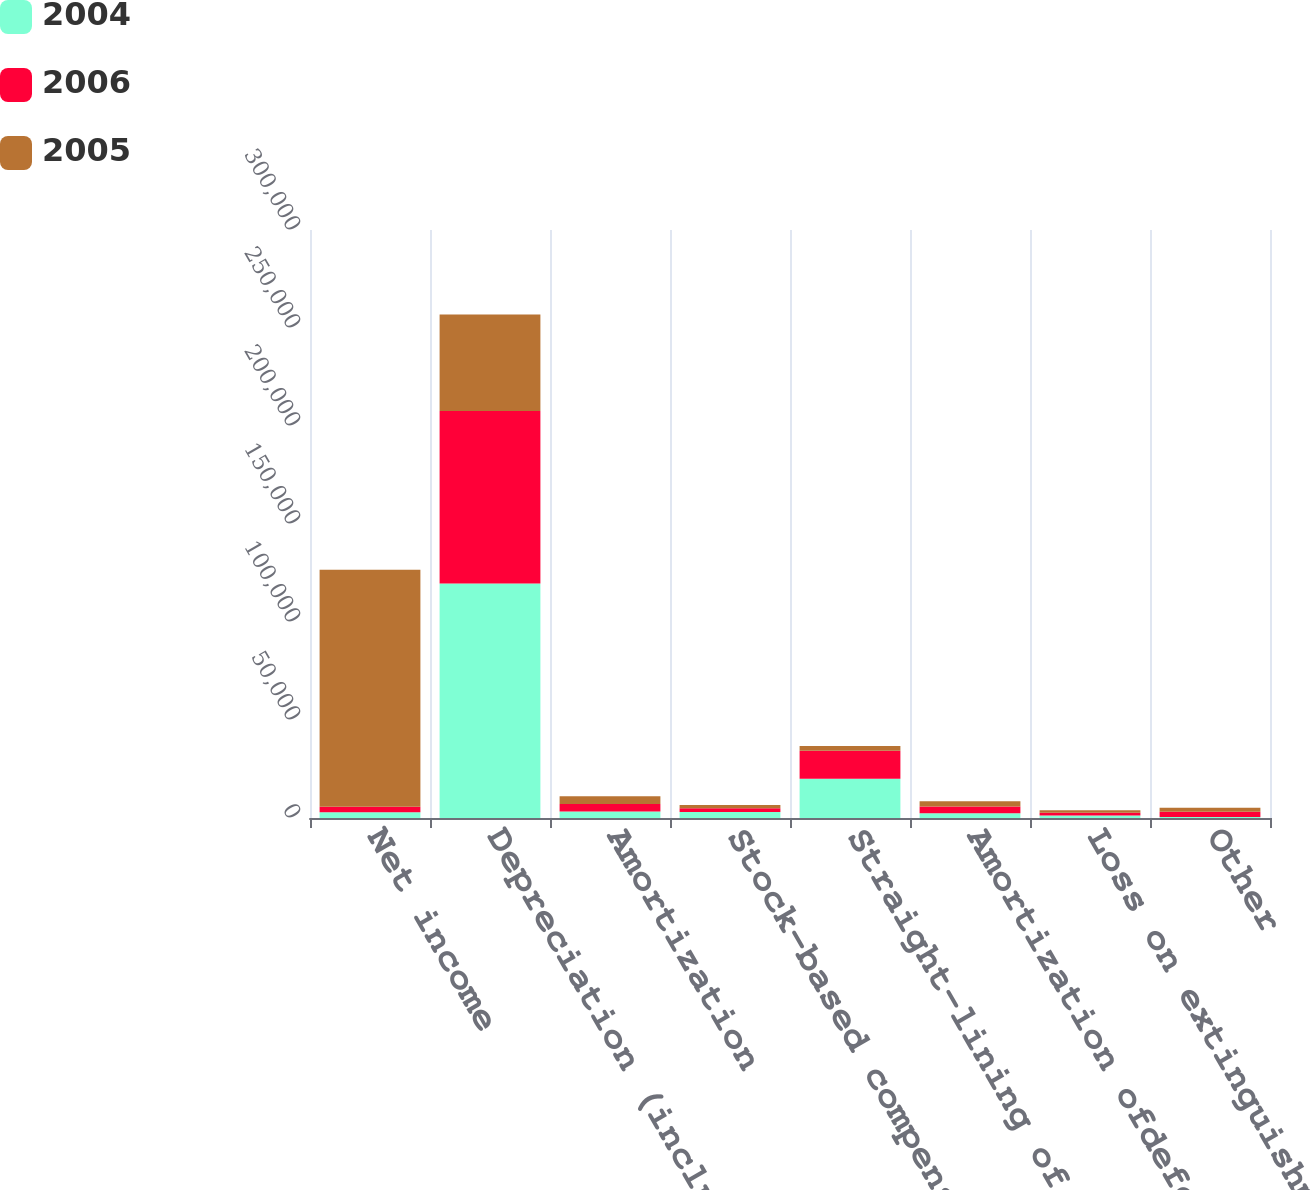Convert chart to OTSL. <chart><loc_0><loc_0><loc_500><loc_500><stacked_bar_chart><ecel><fcel>Net income<fcel>Depreciation (including<fcel>Amortization<fcel>Stock-based compensation<fcel>Straight-lining of<fcel>Amortization ofdeferred<fcel>Loss on extinguishment ofdebt<fcel>Other<nl><fcel>2004<fcel>2872<fcel>119653<fcel>3253<fcel>3046<fcel>19963<fcel>2412<fcel>1273<fcel>488<nl><fcel>2006<fcel>2872<fcel>88002<fcel>3891<fcel>1971<fcel>14287<fcel>3497<fcel>1358<fcel>2698<nl><fcel>2005<fcel>120900<fcel>49238<fcel>3895<fcel>1664<fcel>2462<fcel>2577<fcel>1370<fcel>2016<nl></chart> 